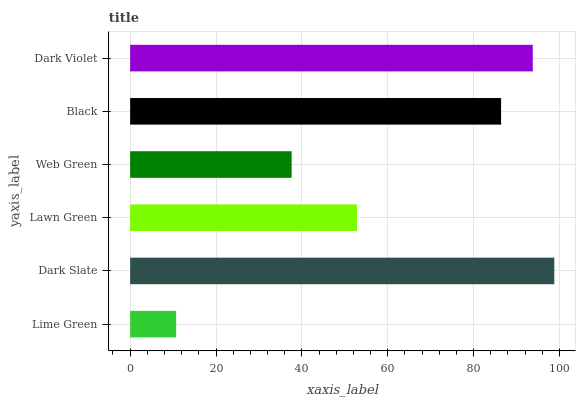Is Lime Green the minimum?
Answer yes or no. Yes. Is Dark Slate the maximum?
Answer yes or no. Yes. Is Lawn Green the minimum?
Answer yes or no. No. Is Lawn Green the maximum?
Answer yes or no. No. Is Dark Slate greater than Lawn Green?
Answer yes or no. Yes. Is Lawn Green less than Dark Slate?
Answer yes or no. Yes. Is Lawn Green greater than Dark Slate?
Answer yes or no. No. Is Dark Slate less than Lawn Green?
Answer yes or no. No. Is Black the high median?
Answer yes or no. Yes. Is Lawn Green the low median?
Answer yes or no. Yes. Is Dark Violet the high median?
Answer yes or no. No. Is Dark Violet the low median?
Answer yes or no. No. 